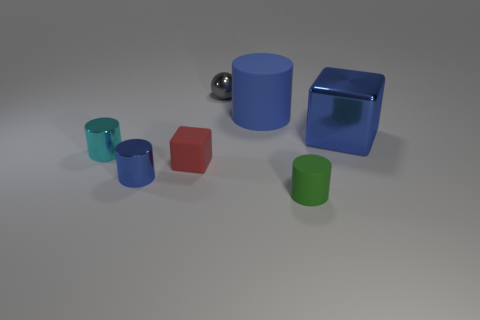Are there any green objects that are on the right side of the tiny thing that is on the right side of the gray shiny ball?
Give a very brief answer. No. How many cubes are the same size as the gray sphere?
Give a very brief answer. 1. There is a block that is left of the large blue object left of the big blue shiny object; what number of tiny green things are to the left of it?
Offer a very short reply. 0. What number of metal objects are both on the right side of the tiny green matte cylinder and to the left of the tiny matte cylinder?
Give a very brief answer. 0. Is there anything else of the same color as the metallic sphere?
Give a very brief answer. No. How many metallic objects are either large blue things or cylinders?
Make the answer very short. 3. There is a small object behind the matte object behind the large metal block on the right side of the cyan cylinder; what is it made of?
Ensure brevity in your answer.  Metal. There is a block that is to the right of the small rubber thing that is on the left side of the gray sphere; what is it made of?
Your response must be concise. Metal. There is a blue object that is to the left of the gray shiny thing; is it the same size as the block to the left of the gray ball?
Your response must be concise. Yes. Is there any other thing that has the same material as the large blue cylinder?
Provide a succinct answer. Yes. 